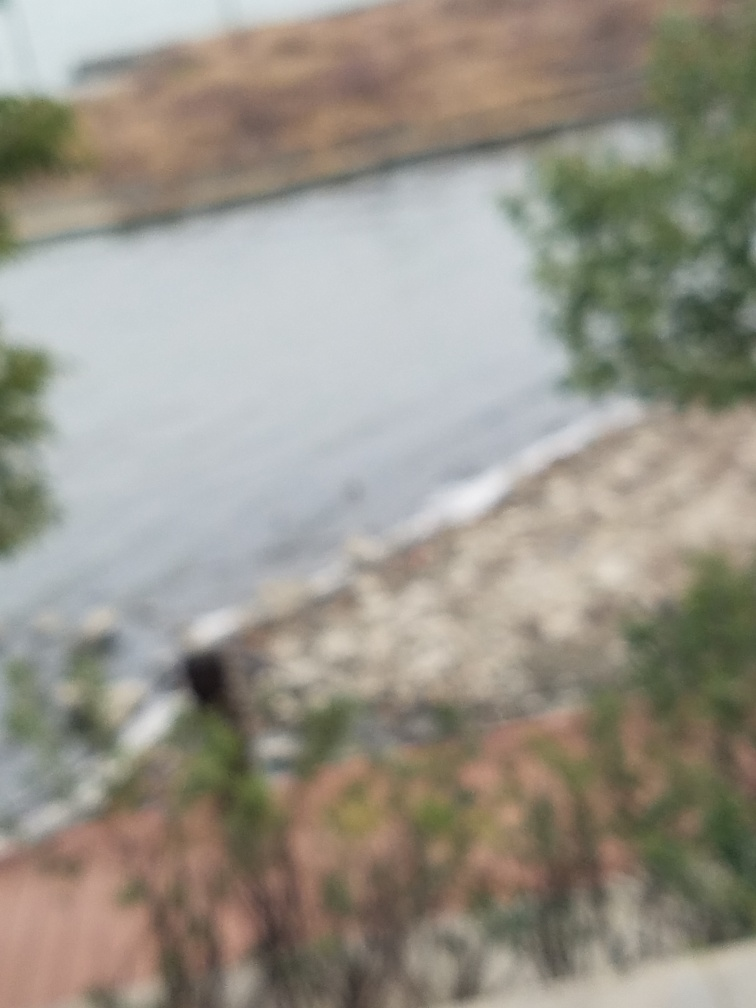Could the image be improved through post-processing? A blurred image like this is difficult to correct through post-processing. Sharpness can be somewhat improved with software, but it cannot recreate the details that were not captured originally. 